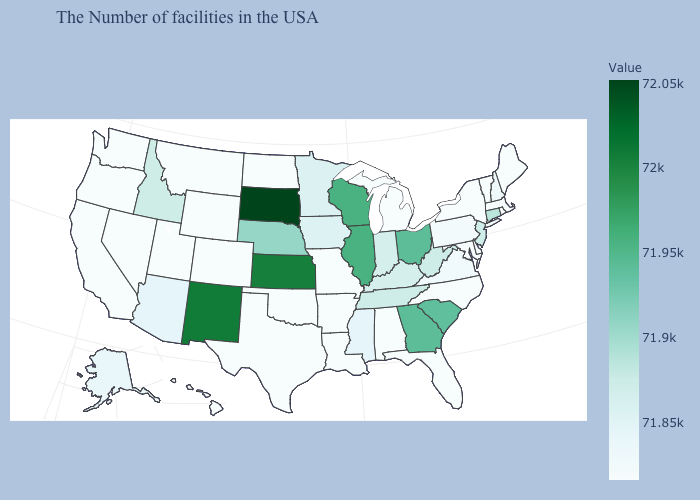Among the states that border New Jersey , does Pennsylvania have the highest value?
Give a very brief answer. Yes. Among the states that border Rhode Island , does Massachusetts have the highest value?
Short answer required. No. Does Rhode Island have a lower value than Kansas?
Concise answer only. Yes. Among the states that border Georgia , does Tennessee have the lowest value?
Keep it brief. No. Does Arizona have the lowest value in the USA?
Be succinct. No. Does the map have missing data?
Quick response, please. No. 